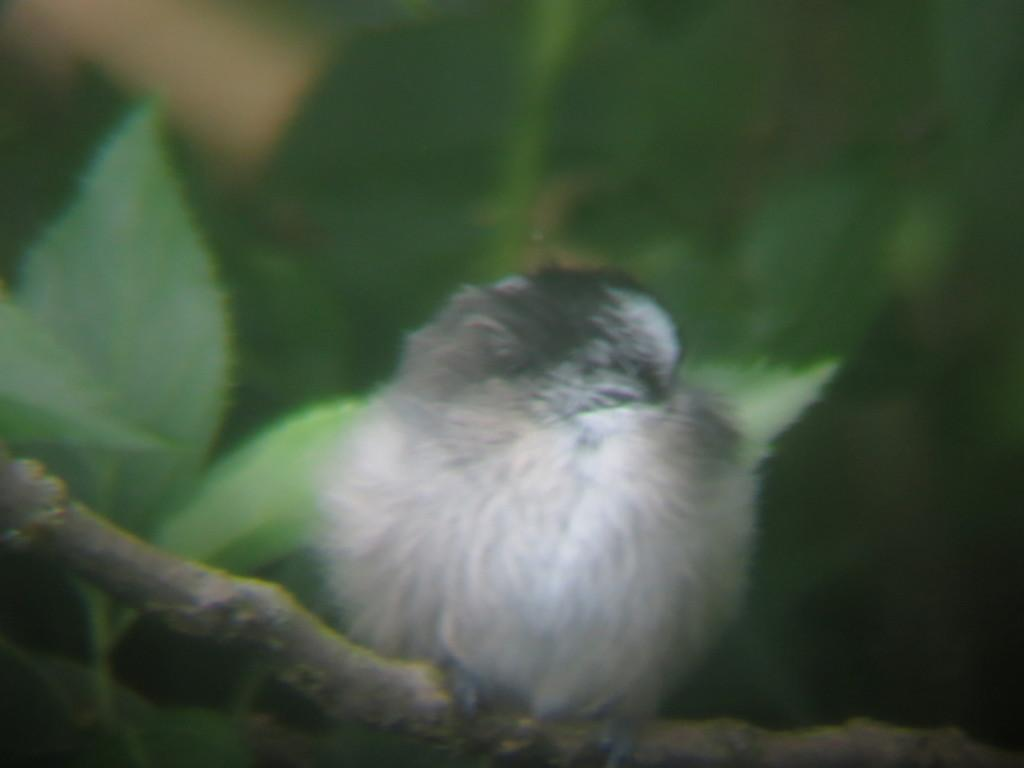What type of animal can be seen in the image? There is a bird in the image. Where is the bird located? The bird is on a branch. What can be seen in the background of the image? The background of the image is blurry, and there are leaves visible. What type of picture is the bird biting in the image? There is no picture present in the image, nor is the bird biting anything. 